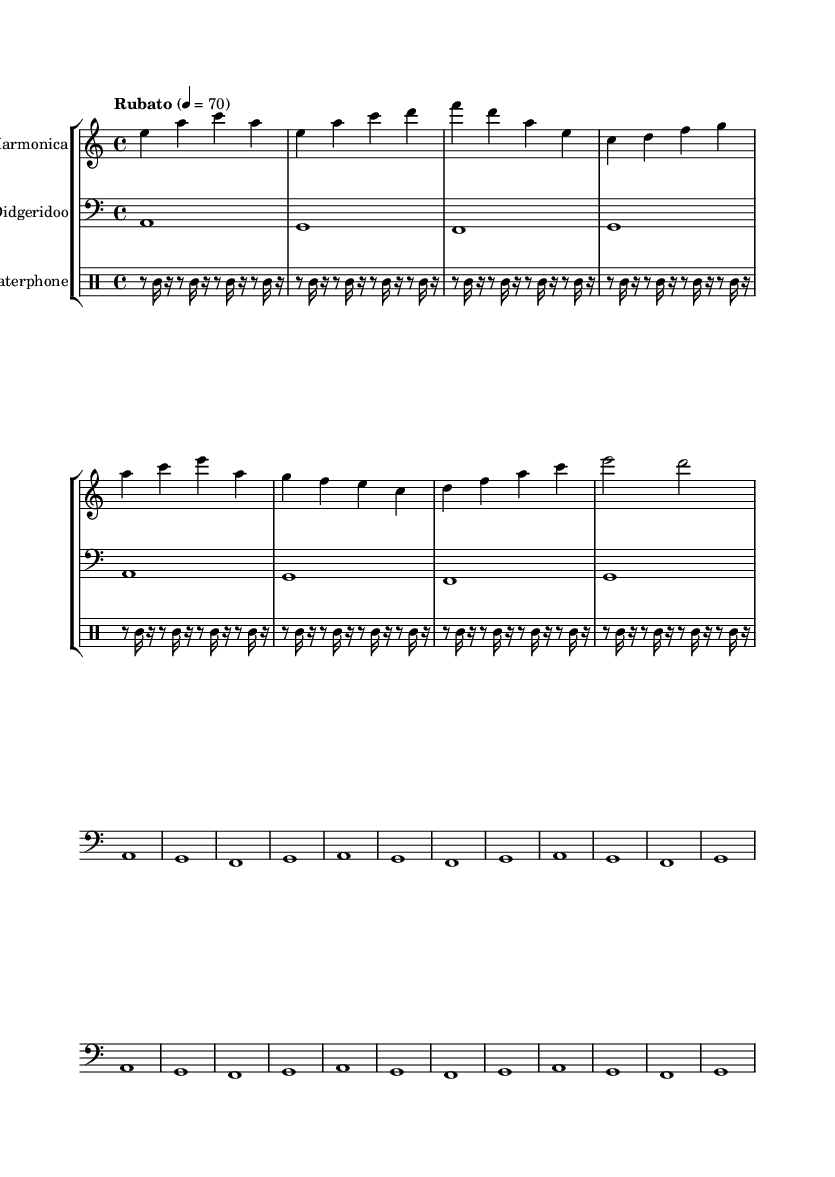What is the key signature of this music? The key signature is A minor, which has one sharp (G#) but is not shown as accidentals in the provided segment.
Answer: A minor What is the time signature of the piece? The time signature is 4/4, which can be determined by the fraction shown at the beginning of the score, indicating four beats per measure.
Answer: 4/4 What is the tempo marking of the music? The tempo marking is "Rubato" at a speed of 70 beats per minute, indicating a flexible tempo.
Answer: Rubato 70 How many measures are in the intro section? There are four measures in the intro section indicated by the first four lines of music before the verse starts.
Answer: 4 What is the primary instrument playing the melody? The primary instrument playing the melody is the glass harmonica, as shown by the treble staff notated at the beginning of the score.
Answer: Glass Harmonica What is the role of the waterphone in this piece? The waterphone provides rhythmic texture as demonstrated by the drum mode notation without specific pitch, filling out the sound.
Answer: Rhythmic texture How does the didgeridoo contribute to the overall sound? The didgeridoo contributes a deep, droning bass line, repeating its notes to create a foundation for the harmonic elements above.
Answer: Deep bass line 